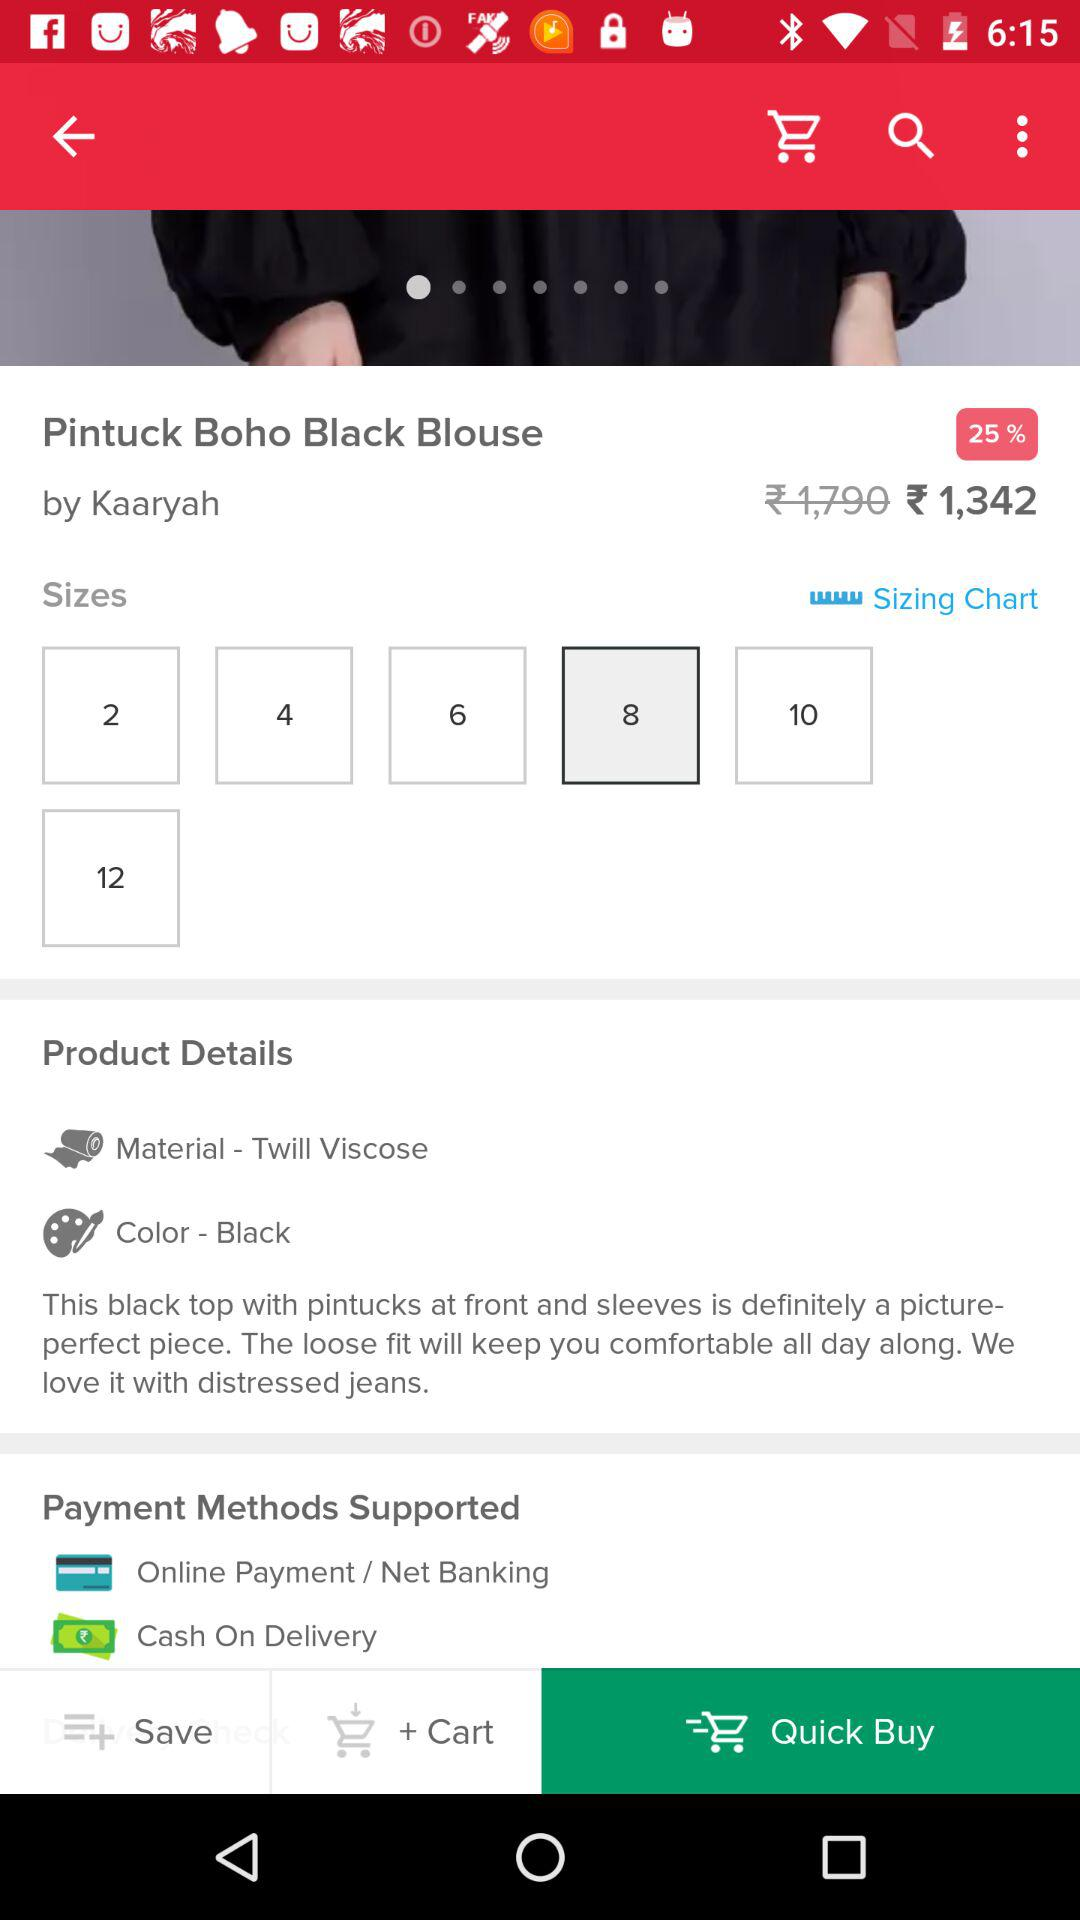What payment methods are supported? The supported payment methods are "Online Payment/Net Banking" and "Cash On Delivery". 